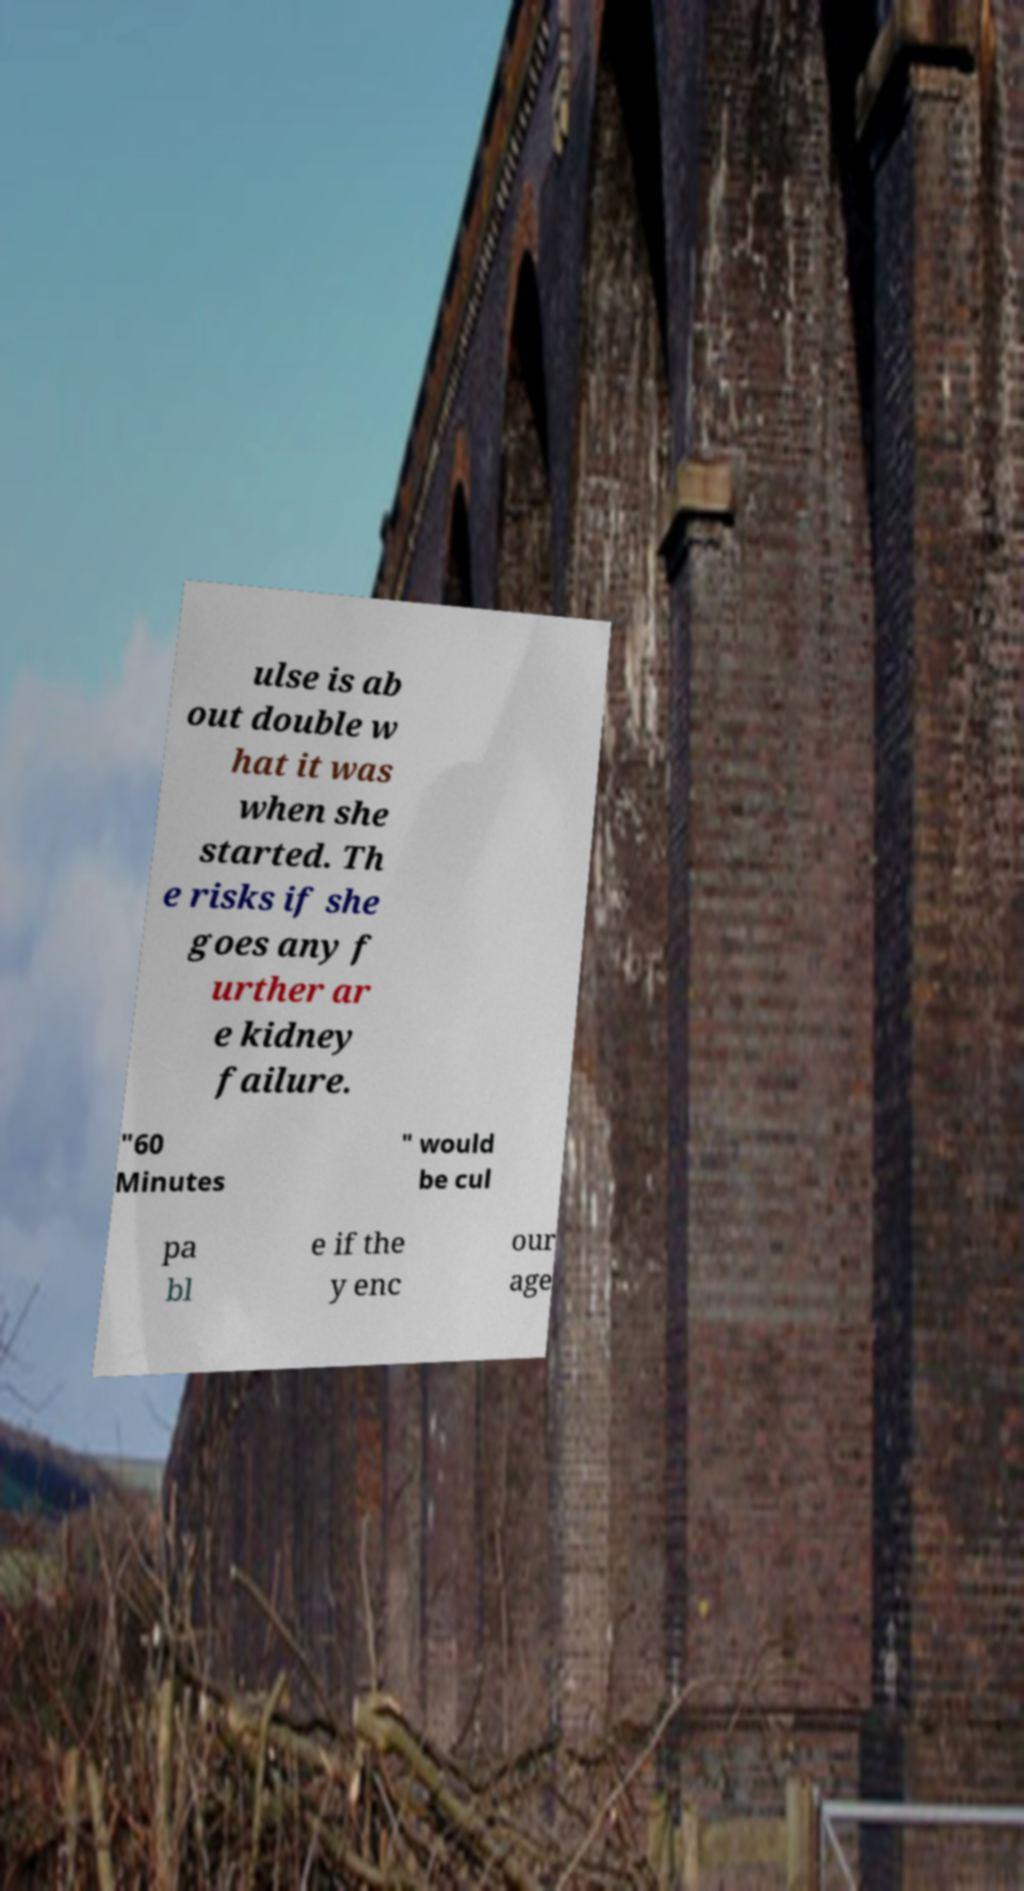What messages or text are displayed in this image? I need them in a readable, typed format. ulse is ab out double w hat it was when she started. Th e risks if she goes any f urther ar e kidney failure. "60 Minutes " would be cul pa bl e if the y enc our age 